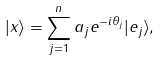Convert formula to latex. <formula><loc_0><loc_0><loc_500><loc_500>| x \rangle = \sum _ { j = 1 } ^ { n } a _ { j } e ^ { - i \theta _ { j } } | e _ { j } \rangle ,</formula> 